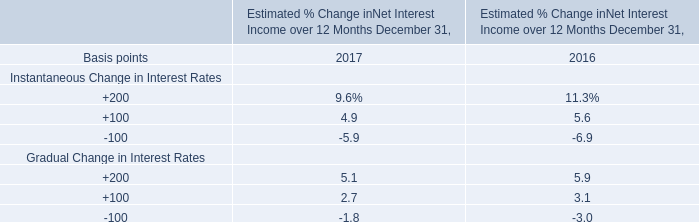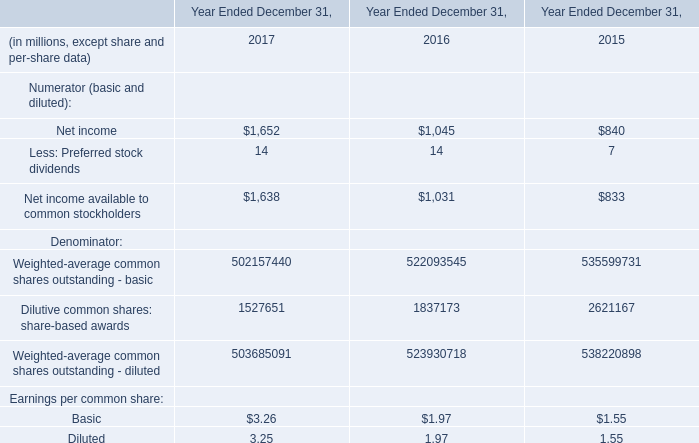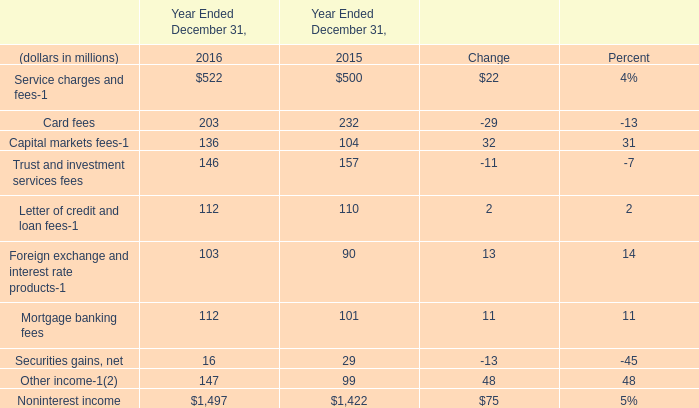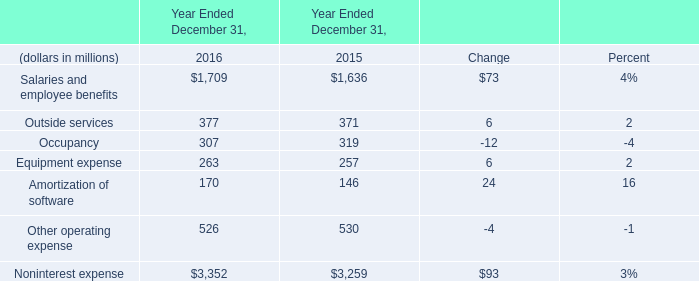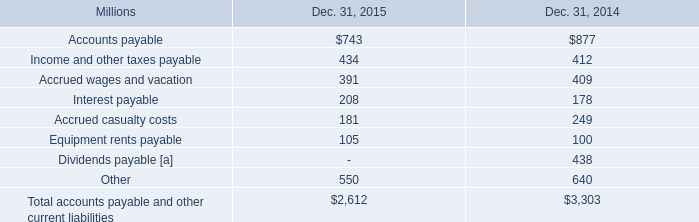what was the percentage change in equipment rents payable from 2014 to 2015? 
Computations: ((105 - 100) / 100)
Answer: 0.05. 